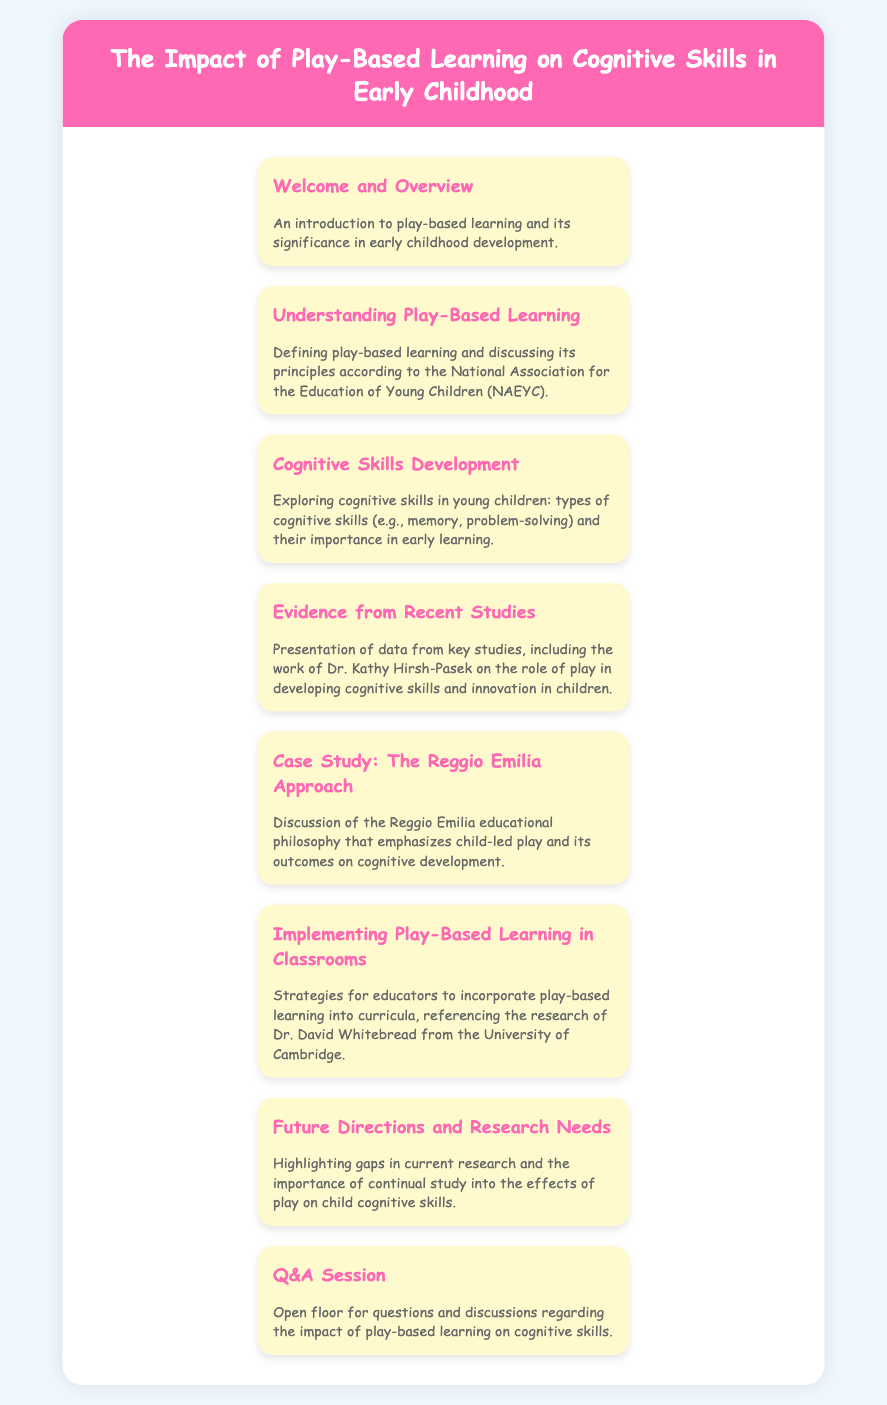What is the title of the conference? The title of the conference is "The Impact of Play-Based Learning on Cognitive Skills in Early Childhood."
Answer: The Impact of Play-Based Learning on Cognitive Skills in Early Childhood Who is discussed in the "Evidence from Recent Studies" section? The section presents data from key studies, including the work of Dr. Kathy Hirsh-Pasek.
Answer: Dr. Kathy Hirsh-Pasek What educational philosophy is discussed in the case study? The case study discusses the Reggio Emilia educational philosophy.
Answer: Reggio Emilia What is one type of cognitive skill mentioned? The document mentions memory as one type of cognitive skill.
Answer: Memory Which approach does Dr. David Whitebread’s research focus on? The document states Dr. David Whitebread's research focuses on implementing play-based learning in classrooms.
Answer: Implementing play-based learning in classrooms What session is held at the end of the conference? The document outlines an open floor for questions and discussions called the Q&A session.
Answer: Q&A Session 